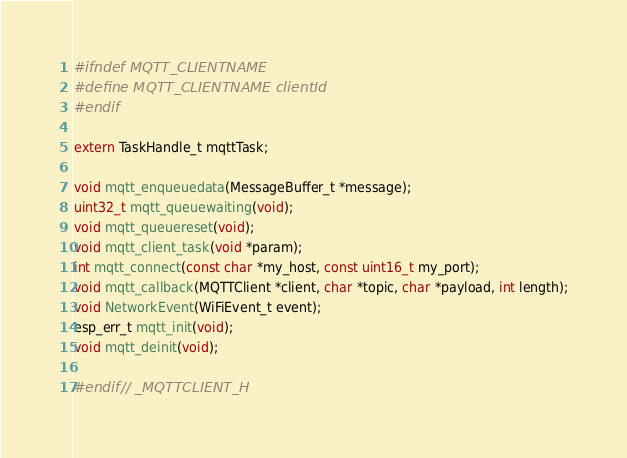Convert code to text. <code><loc_0><loc_0><loc_500><loc_500><_C_>#ifndef MQTT_CLIENTNAME
#define MQTT_CLIENTNAME clientId
#endif

extern TaskHandle_t mqttTask;

void mqtt_enqueuedata(MessageBuffer_t *message);
uint32_t mqtt_queuewaiting(void);
void mqtt_queuereset(void);
void mqtt_client_task(void *param);
int mqtt_connect(const char *my_host, const uint16_t my_port);
void mqtt_callback(MQTTClient *client, char *topic, char *payload, int length);
void NetworkEvent(WiFiEvent_t event);
esp_err_t mqtt_init(void);
void mqtt_deinit(void);

#endif // _MQTTCLIENT_H</code> 